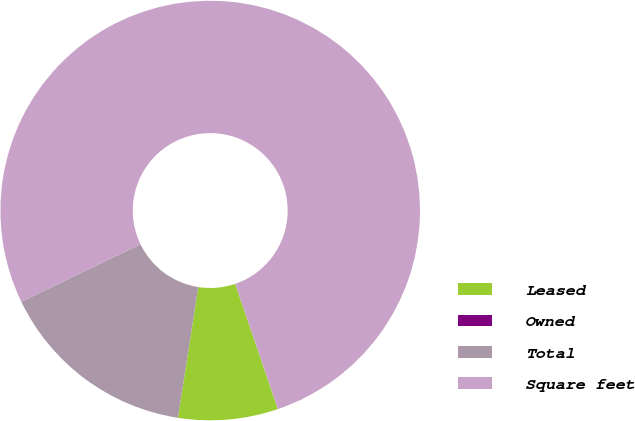Convert chart to OTSL. <chart><loc_0><loc_0><loc_500><loc_500><pie_chart><fcel>Leased<fcel>Owned<fcel>Total<fcel>Square feet<nl><fcel>7.69%<fcel>0.0%<fcel>15.38%<fcel>76.92%<nl></chart> 